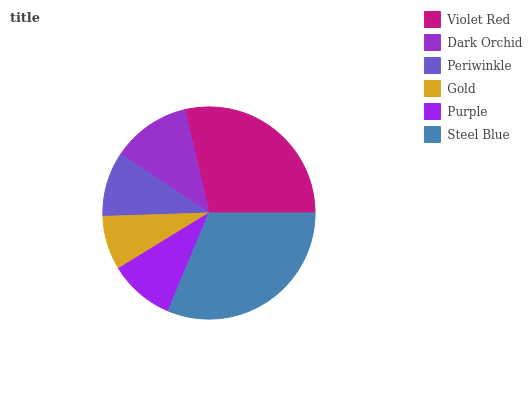Is Gold the minimum?
Answer yes or no. Yes. Is Steel Blue the maximum?
Answer yes or no. Yes. Is Dark Orchid the minimum?
Answer yes or no. No. Is Dark Orchid the maximum?
Answer yes or no. No. Is Violet Red greater than Dark Orchid?
Answer yes or no. Yes. Is Dark Orchid less than Violet Red?
Answer yes or no. Yes. Is Dark Orchid greater than Violet Red?
Answer yes or no. No. Is Violet Red less than Dark Orchid?
Answer yes or no. No. Is Dark Orchid the high median?
Answer yes or no. Yes. Is Purple the low median?
Answer yes or no. Yes. Is Steel Blue the high median?
Answer yes or no. No. Is Violet Red the low median?
Answer yes or no. No. 